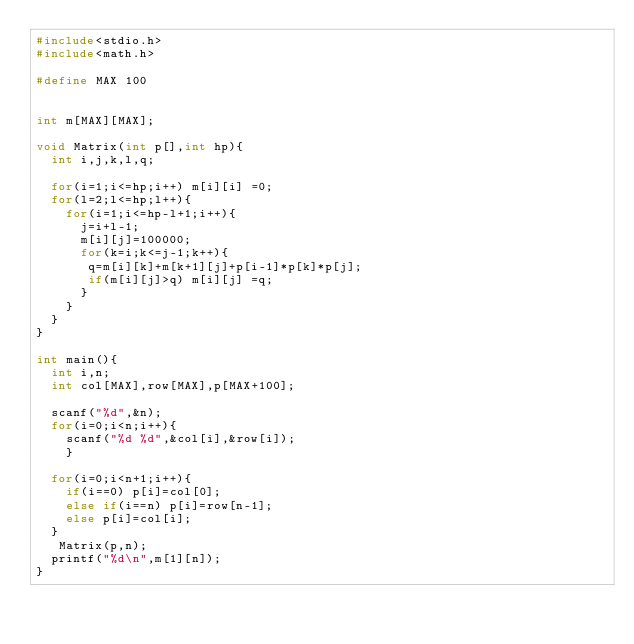Convert code to text. <code><loc_0><loc_0><loc_500><loc_500><_C_>#include<stdio.h>
#include<math.h>

#define MAX 100

 
int m[MAX][MAX];
 
void Matrix(int p[],int hp){
  int i,j,k,l,q;

  for(i=1;i<=hp;i++) m[i][i] =0;
  for(l=2;l<=hp;l++){
    for(i=1;i<=hp-l+1;i++){
      j=i+l-1;
      m[i][j]=100000;
      for(k=i;k<=j-1;k++){
       q=m[i][k]+m[k+1][j]+p[i-1]*p[k]*p[j];
       if(m[i][j]>q) m[i][j] =q;
      }
    }
  }
}
 
int main(){
  int i,n;
  int col[MAX],row[MAX],p[MAX+100];
  
  scanf("%d",&n);
  for(i=0;i<n;i++){
    scanf("%d %d",&col[i],&row[i]);
    }
  
  for(i=0;i<n+1;i++){
    if(i==0) p[i]=col[0];
    else if(i==n) p[i]=row[n-1];
    else p[i]=col[i];
  }
   Matrix(p,n);
  printf("%d\n",m[1][n]);
}

</code> 